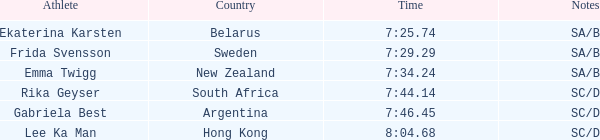What is the time of frida svensson's race that had sa/b under the notes? 7:29.29. 